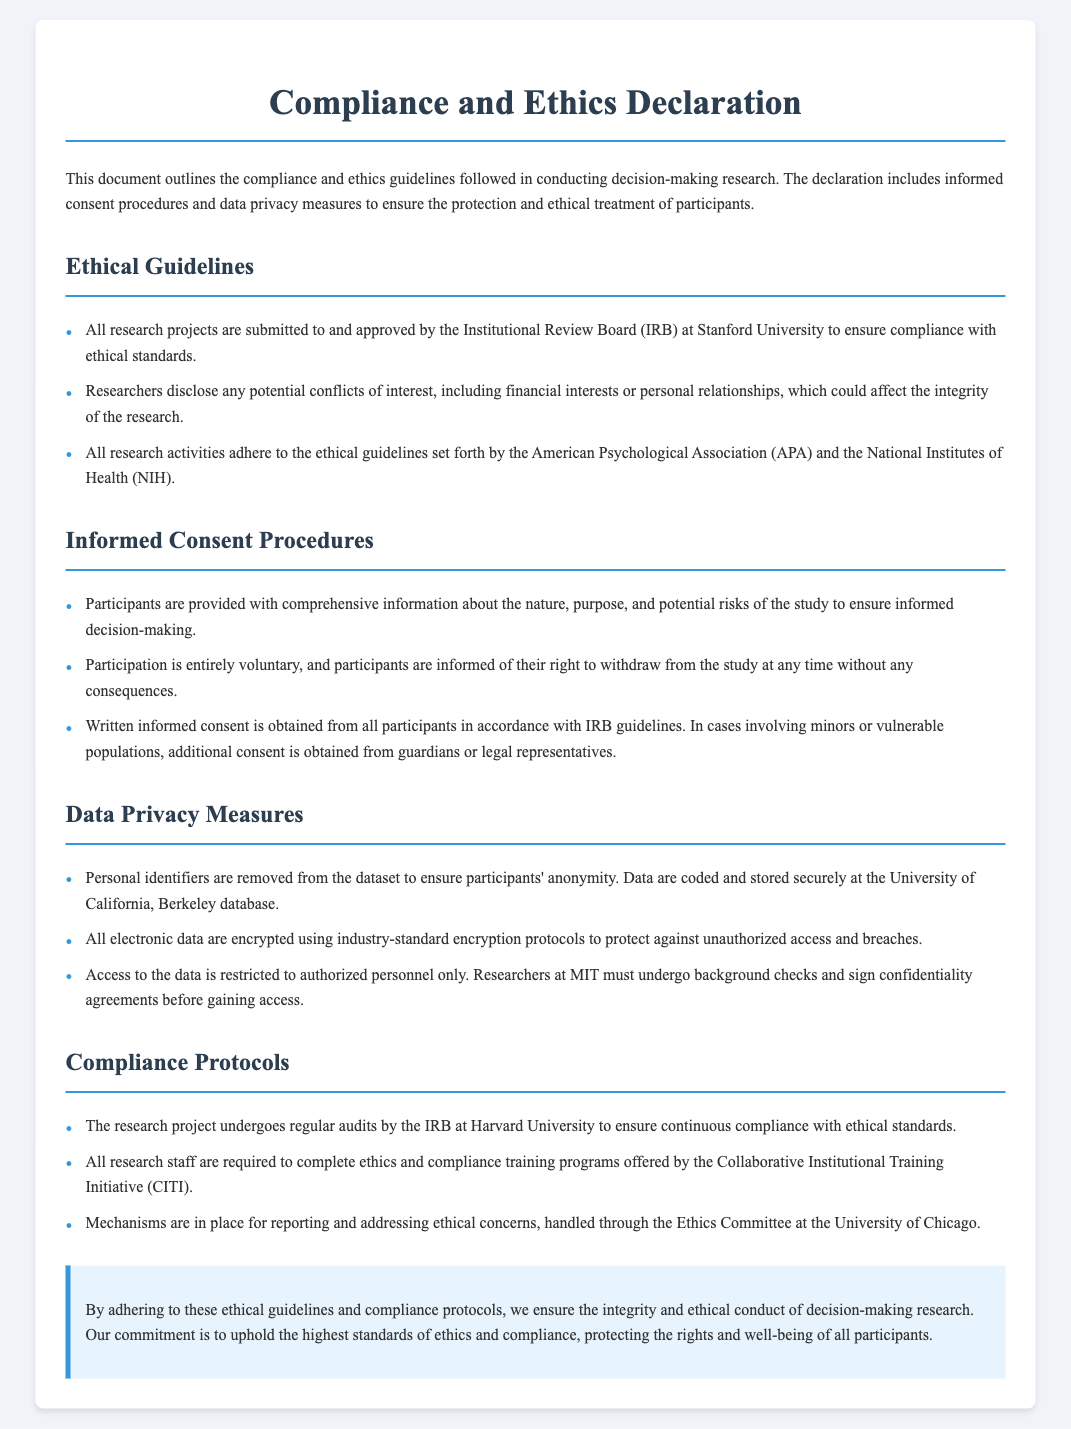what is the title of the document? The title is presented at the top of the document as the main heading.
Answer: Compliance and Ethics Declaration which institution's IRB approves the research projects? This information is provided under the ethical guidelines section.
Answer: Stanford University what organization’s guidelines are followed in the research? This information can be found in the section discussing ethical guidelines.
Answer: American Psychological Association how often does the research project undergo audits? The frequency of audits is mentioned in the compliance protocols section.
Answer: Regularly what type of consent is obtained from participants? This is specified in the informed consent procedures section of the document.
Answer: Written informed consent who must complete ethics training programs? This is explained under the compliance protocols section regarding staff requirements.
Answer: All research staff what happens to personal identifiers in the dataset? The data privacy measures section addresses the handling of personal identifiers.
Answer: Removed which committee handles ethical concerns? The document specifies the committee responsible for ethical concerns in the compliance protocols section.
Answer: Ethics Committee at the University of Chicago 